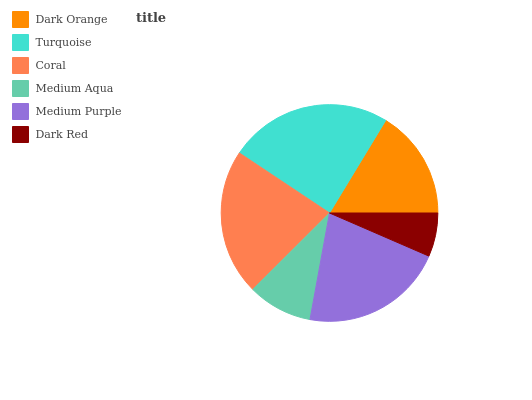Is Dark Red the minimum?
Answer yes or no. Yes. Is Turquoise the maximum?
Answer yes or no. Yes. Is Coral the minimum?
Answer yes or no. No. Is Coral the maximum?
Answer yes or no. No. Is Turquoise greater than Coral?
Answer yes or no. Yes. Is Coral less than Turquoise?
Answer yes or no. Yes. Is Coral greater than Turquoise?
Answer yes or no. No. Is Turquoise less than Coral?
Answer yes or no. No. Is Medium Purple the high median?
Answer yes or no. Yes. Is Dark Orange the low median?
Answer yes or no. Yes. Is Turquoise the high median?
Answer yes or no. No. Is Medium Purple the low median?
Answer yes or no. No. 